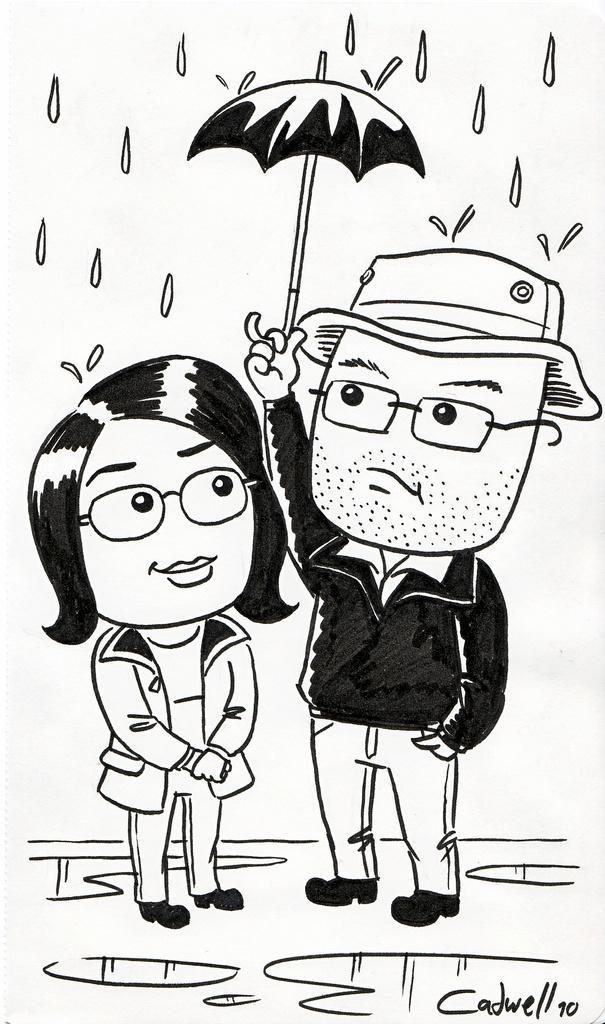Please provide a concise description of this image. This is an animated picture, in this image we can see two persons, among them one person is holding an umbrella and also we can see it's raining. 